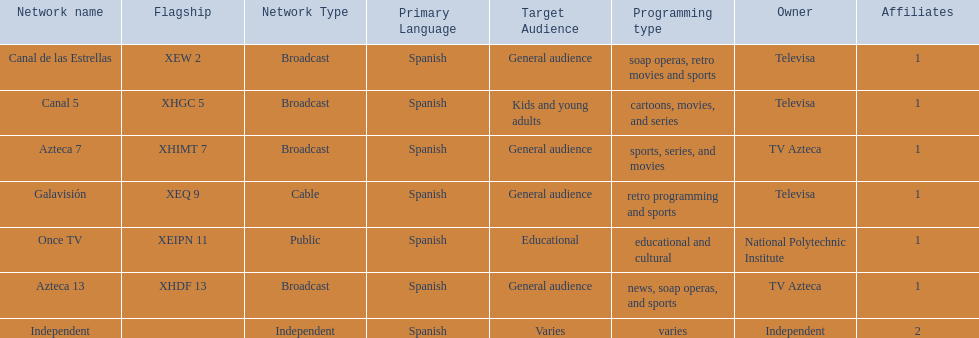How many networks do not telecast sports? 2. 